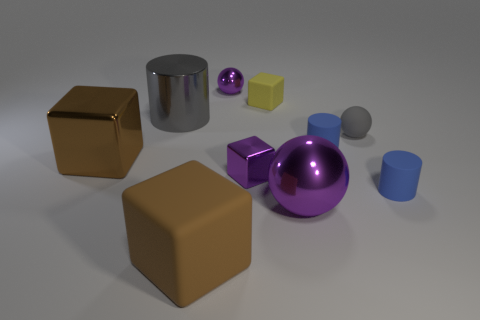Subtract all cylinders. How many objects are left? 7 Subtract all big brown matte objects. Subtract all tiny purple blocks. How many objects are left? 8 Add 7 tiny blue matte objects. How many tiny blue matte objects are left? 9 Add 6 tiny blue matte spheres. How many tiny blue matte spheres exist? 6 Subtract 0 cyan balls. How many objects are left? 10 